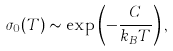Convert formula to latex. <formula><loc_0><loc_0><loc_500><loc_500>\sigma _ { 0 } ( T ) \sim \exp \left ( - \frac { C } { k _ { B } T } \right ) ,</formula> 